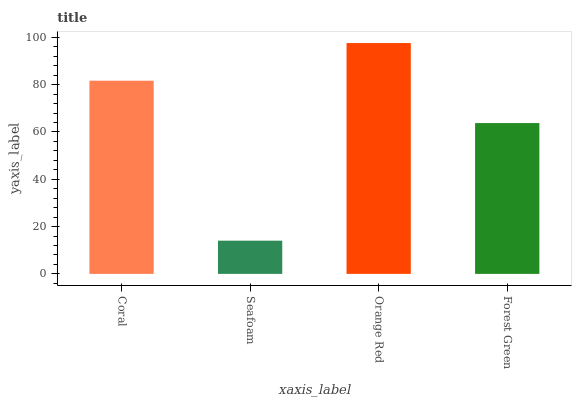Is Orange Red the minimum?
Answer yes or no. No. Is Seafoam the maximum?
Answer yes or no. No. Is Orange Red greater than Seafoam?
Answer yes or no. Yes. Is Seafoam less than Orange Red?
Answer yes or no. Yes. Is Seafoam greater than Orange Red?
Answer yes or no. No. Is Orange Red less than Seafoam?
Answer yes or no. No. Is Coral the high median?
Answer yes or no. Yes. Is Forest Green the low median?
Answer yes or no. Yes. Is Orange Red the high median?
Answer yes or no. No. Is Coral the low median?
Answer yes or no. No. 